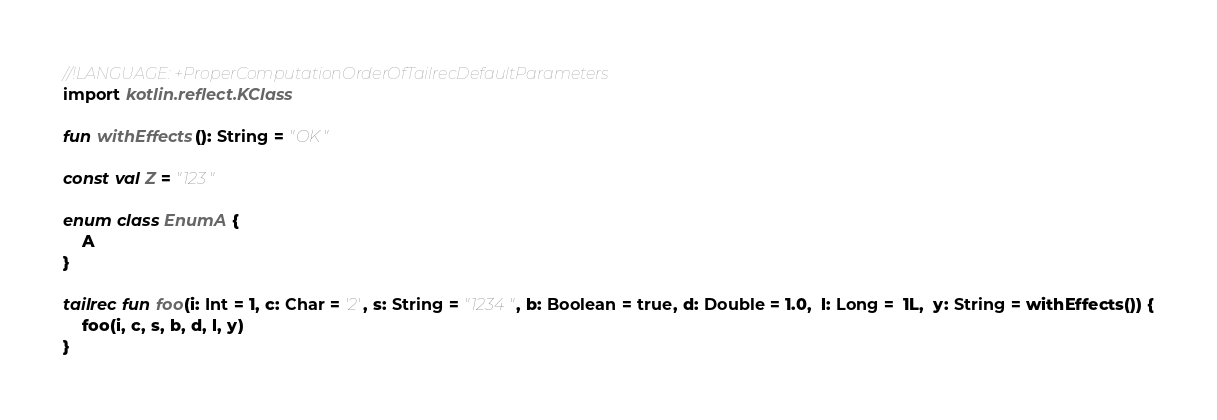<code> <loc_0><loc_0><loc_500><loc_500><_Kotlin_>//!LANGUAGE: +ProperComputationOrderOfTailrecDefaultParameters
import kotlin.reflect.KClass

fun withEffects(): String = "OK"

const val Z = "123"

enum class EnumA {
    A
}

tailrec fun foo(i: Int = 1, c: Char = '2', s: String = "1234", b: Boolean = true, d: Double = 1.0,  l: Long =  1L,  y: String = withEffects()) {
    foo(i, c, s, b, d, l, y)
}

</code> 